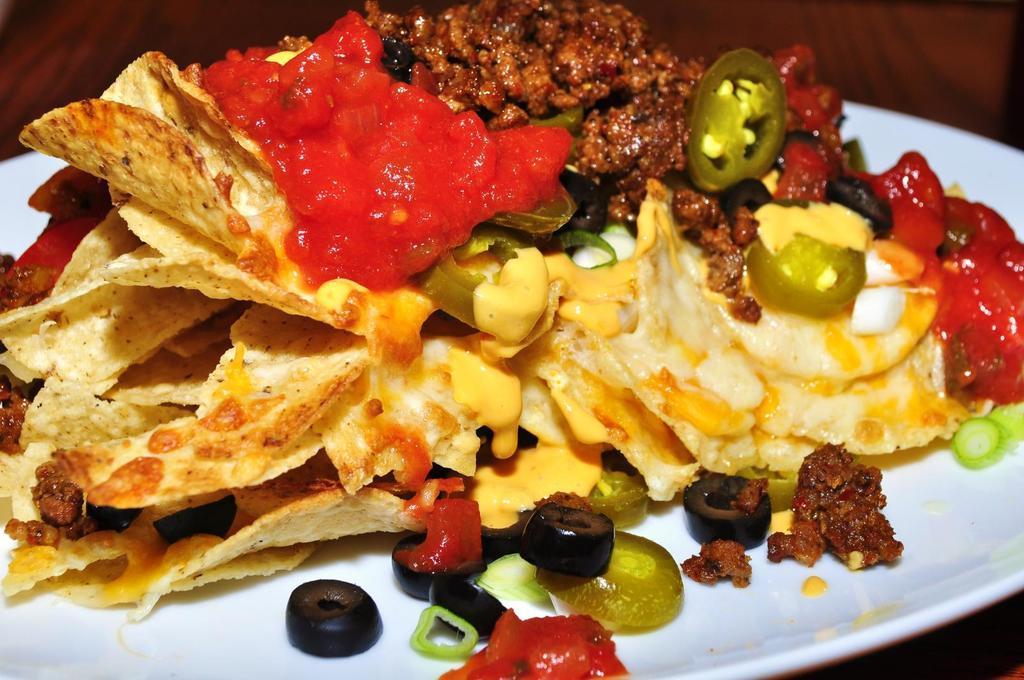In one or two sentences, can you explain what this image depicts? In this image we can see some food item on the plate which is on the table. 